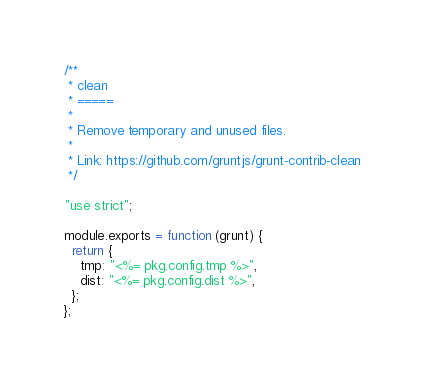Convert code to text. <code><loc_0><loc_0><loc_500><loc_500><_JavaScript_>/**
 * clean
 * =====
 *
 * Remove temporary and unused files.
 *
 * Link: https://github.com/gruntjs/grunt-contrib-clean
 */

"use strict";

module.exports = function (grunt) {
  return {
    tmp: "<%= pkg.config.tmp %>",
    dist: "<%= pkg.config.dist %>",
  };
};
</code> 